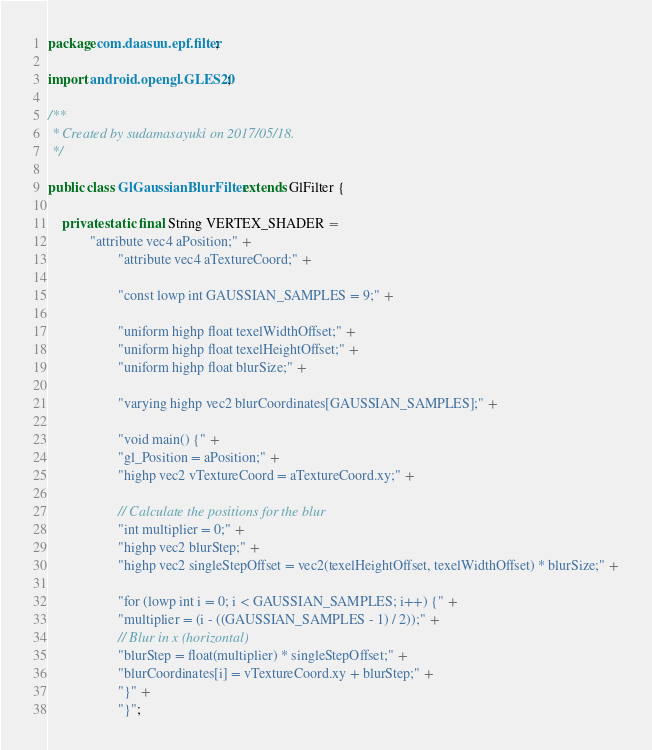<code> <loc_0><loc_0><loc_500><loc_500><_Java_>package com.daasuu.epf.filter;

import android.opengl.GLES20;

/**
 * Created by sudamasayuki on 2017/05/18.
 */

public class GlGaussianBlurFilter extends GlFilter {

    private static final String VERTEX_SHADER =
            "attribute vec4 aPosition;" +
                    "attribute vec4 aTextureCoord;" +

                    "const lowp int GAUSSIAN_SAMPLES = 9;" +

                    "uniform highp float texelWidthOffset;" +
                    "uniform highp float texelHeightOffset;" +
                    "uniform highp float blurSize;" +

                    "varying highp vec2 blurCoordinates[GAUSSIAN_SAMPLES];" +

                    "void main() {" +
                    "gl_Position = aPosition;" +
                    "highp vec2 vTextureCoord = aTextureCoord.xy;" +

                    // Calculate the positions for the blur
                    "int multiplier = 0;" +
                    "highp vec2 blurStep;" +
                    "highp vec2 singleStepOffset = vec2(texelHeightOffset, texelWidthOffset) * blurSize;" +

                    "for (lowp int i = 0; i < GAUSSIAN_SAMPLES; i++) {" +
                    "multiplier = (i - ((GAUSSIAN_SAMPLES - 1) / 2));" +
                    // Blur in x (horizontal)
                    "blurStep = float(multiplier) * singleStepOffset;" +
                    "blurCoordinates[i] = vTextureCoord.xy + blurStep;" +
                    "}" +
                    "}";
</code> 